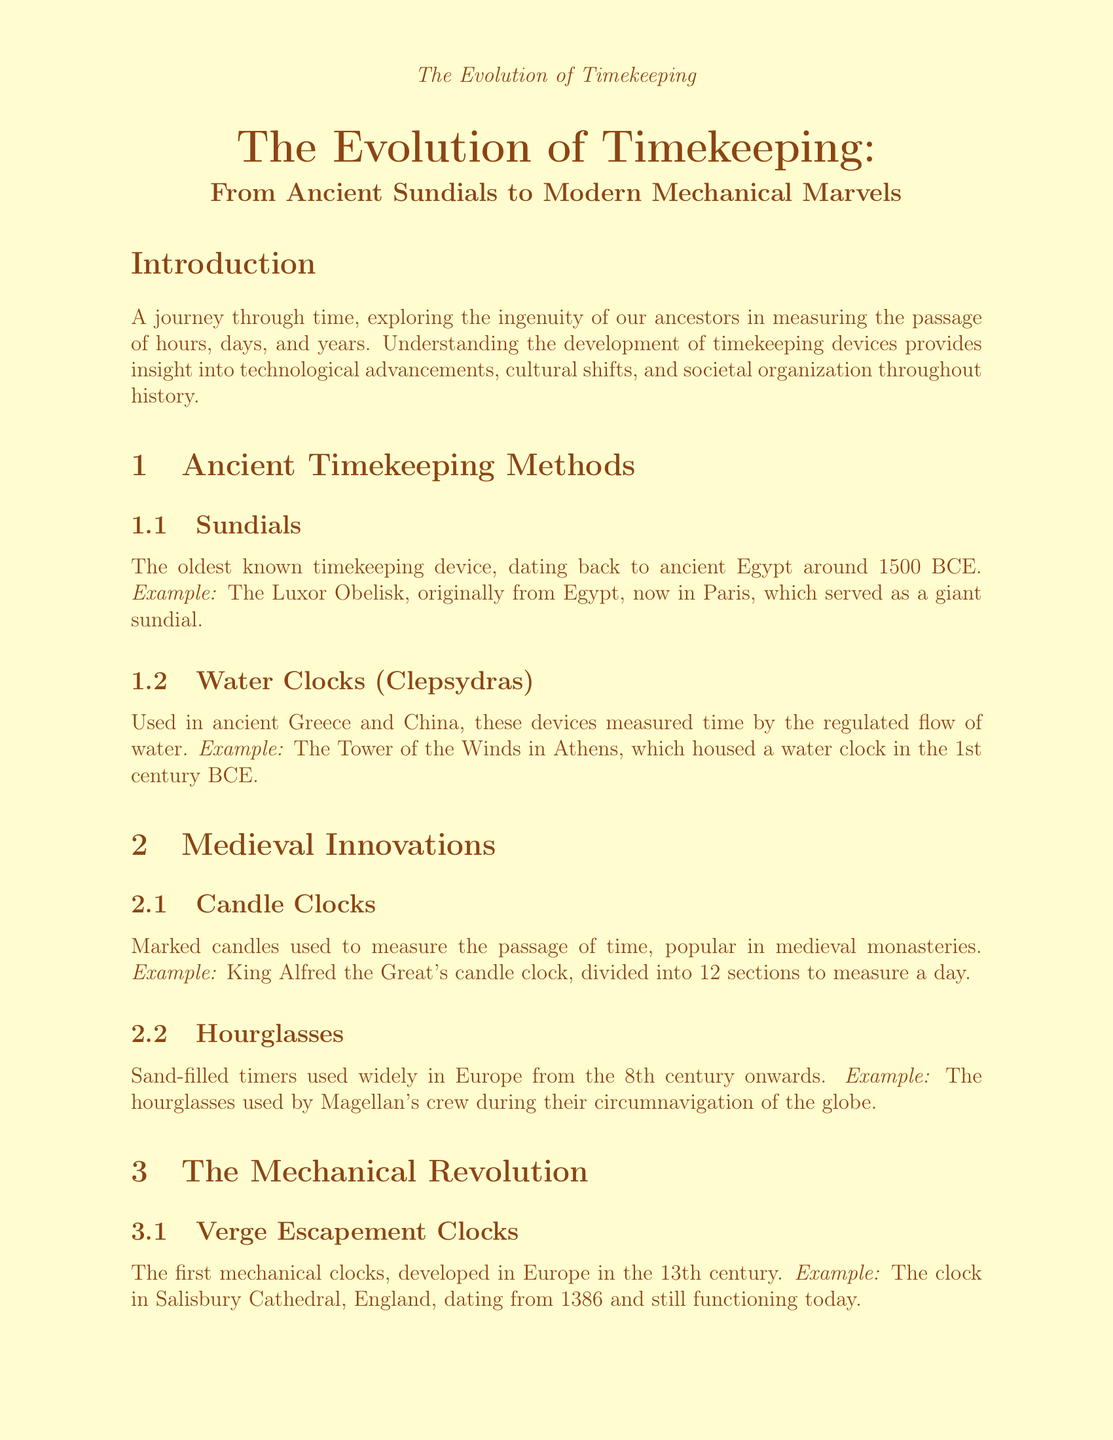What device is the oldest known timekeeping method? The document states that sundials are the oldest known timekeeping device, dating back to ancient Egypt around 1500 BCE.
Answer: Sundials Which timekeeping device was used in ancient Greece and China? The document mentions water clocks (clepsydras) as a method used in both ancient Greece and China to measure time by the regulated flow of water.
Answer: Water Clocks Who invented the pendulum clock? The document indicates that Christiaan Huygens invented the pendulum clock in 1656, greatly improving timekeeping accuracy.
Answer: Christiaan Huygens What significant invention did John Harrison create in the 18th century? The document highlights John Harrison's H4 chronometer as a highly accurate portable timepiece used for determining longitude at sea, which revolutionized maritime navigation.
Answer: H4 chronometer In what year was the first quartz wristwatch released? The document notes that the Seiko Astron, the world's first quartz wristwatch, was released in 1969.
Answer: 1969 How did candle clocks measure time? The document explains that candle clocks marked candles were used to measure the passage of time, popular in medieval monasteries.
Answer: Marked candles What is one activity suggested for the classroom related to timekeeping? The document mentions classroom activities including building a sundial, which involves students creating their own sundials using simple materials.
Answer: Build a Sundial What does the conclusion of the document reflect on humanity's quest? The conclusion states that the evolution of timekeeping devices reflects humanity's constant quest for precision and understanding of our place in time.
Answer: Precision and understanding What feature characterizes marine chronometers? Marine chronometers are described as highly accurate portable timepieces used for determining longitude at sea in the document.
Answer: Highly accurate portable timepieces 